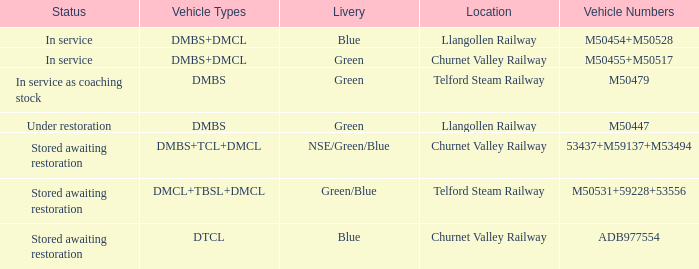What livery has a status of in service as coaching stock? Green. 